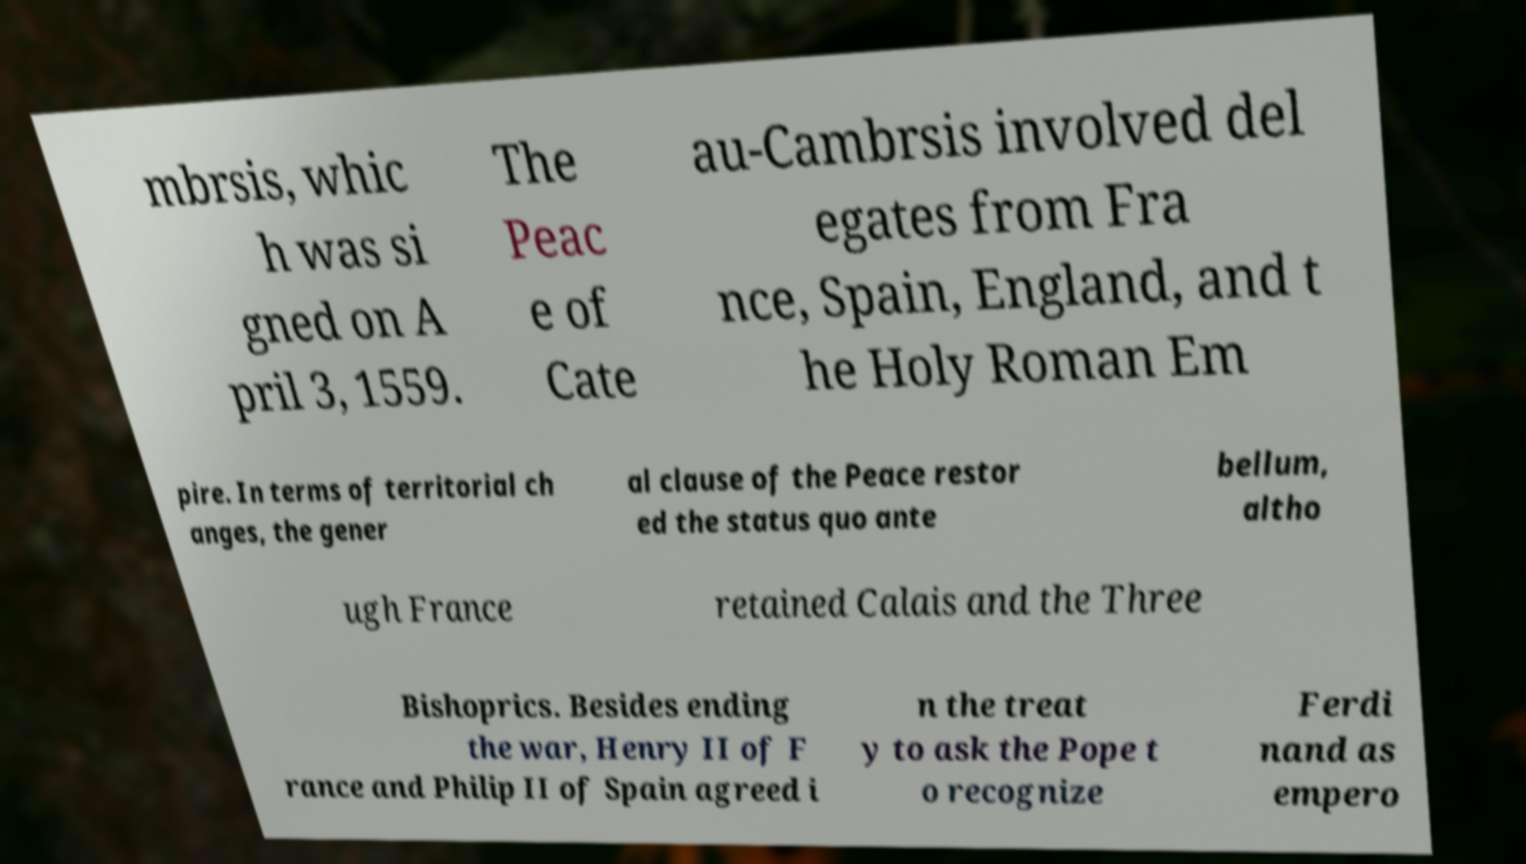There's text embedded in this image that I need extracted. Can you transcribe it verbatim? mbrsis, whic h was si gned on A pril 3, 1559. The Peac e of Cate au-Cambrsis involved del egates from Fra nce, Spain, England, and t he Holy Roman Em pire. In terms of territorial ch anges, the gener al clause of the Peace restor ed the status quo ante bellum, altho ugh France retained Calais and the Three Bishoprics. Besides ending the war, Henry II of F rance and Philip II of Spain agreed i n the treat y to ask the Pope t o recognize Ferdi nand as empero 